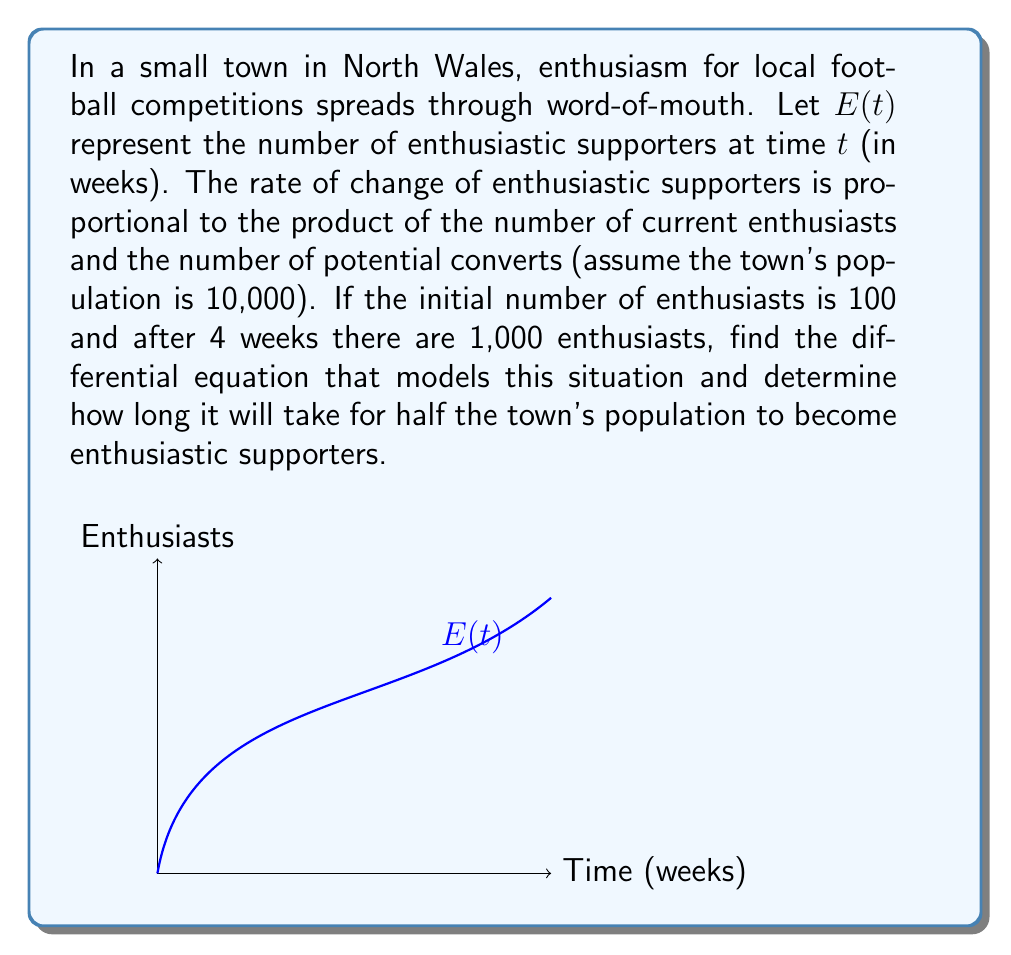Give your solution to this math problem. 1) Let's start by formulating the differential equation:
   $$\frac{dE}{dt} = kE(10000 - E)$$
   where $k$ is the proportionality constant.

2) We're given two conditions:
   At $t = 0$, $E = 100$
   At $t = 4$, $E = 1000$

3) To find $k$, we can use the solution to this logistic differential equation:
   $$E(t) = \frac{10000}{1 + (\frac{10000}{100} - 1)e^{-10000kt}}$$

4) Substituting the second condition:
   $$1000 = \frac{10000}{1 + 99e^{-40000k}}$$

5) Solving this equation:
   $$99e^{-40000k} = 9$$
   $$e^{-40000k} = \frac{1}{11}$$
   $$-40000k = \ln(\frac{1}{11})$$
   $$k = \frac{\ln(11)}{40000} \approx 0.0000601$$

6) Now, to find when half the population becomes enthusiastic:
   We need to solve $E(t) = 5000$

7) Using the logistic equation:
   $$5000 = \frac{10000}{1 + 99e^{-10000kt}}$$

8) Solving for $t$:
   $$1 = 99e^{-10000kt}$$
   $$\ln(\frac{1}{99}) = -10000kt$$
   $$t = \frac{\ln(99)}{10000k} \approx 76.2$$

Therefore, it will take approximately 76.2 weeks for half the town's population to become enthusiastic supporters.
Answer: $\frac{dE}{dt} = 0.0000601E(10000 - E)$; 76.2 weeks 